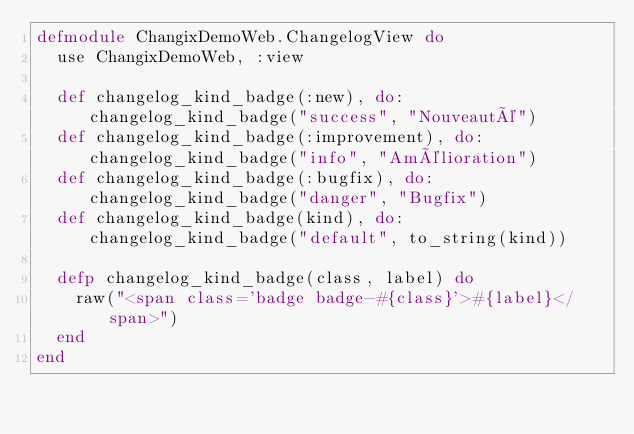<code> <loc_0><loc_0><loc_500><loc_500><_Elixir_>defmodule ChangixDemoWeb.ChangelogView do
  use ChangixDemoWeb, :view

  def changelog_kind_badge(:new), do: changelog_kind_badge("success", "Nouveauté")
  def changelog_kind_badge(:improvement), do: changelog_kind_badge("info", "Amélioration")
  def changelog_kind_badge(:bugfix), do: changelog_kind_badge("danger", "Bugfix")
  def changelog_kind_badge(kind), do: changelog_kind_badge("default", to_string(kind))

  defp changelog_kind_badge(class, label) do
    raw("<span class='badge badge-#{class}'>#{label}</span>")
  end
end
</code> 